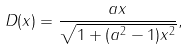<formula> <loc_0><loc_0><loc_500><loc_500>D ( x ) = \frac { a x } { \sqrt { 1 + ( a ^ { 2 } - 1 ) x ^ { 2 } } } ,</formula> 